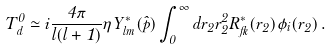Convert formula to latex. <formula><loc_0><loc_0><loc_500><loc_500>T _ { d } ^ { 0 } \simeq i { \frac { 4 \pi } { l ( l + 1 ) } } \eta Y _ { l m } ^ { * } ( { \hat { p } } ) \int _ { 0 } ^ { \infty } d r _ { 2 } r _ { 2 } ^ { 2 } R _ { f l } ^ { * } ( r _ { 2 } ) \phi _ { i } ( r _ { 2 } ) \, .</formula> 